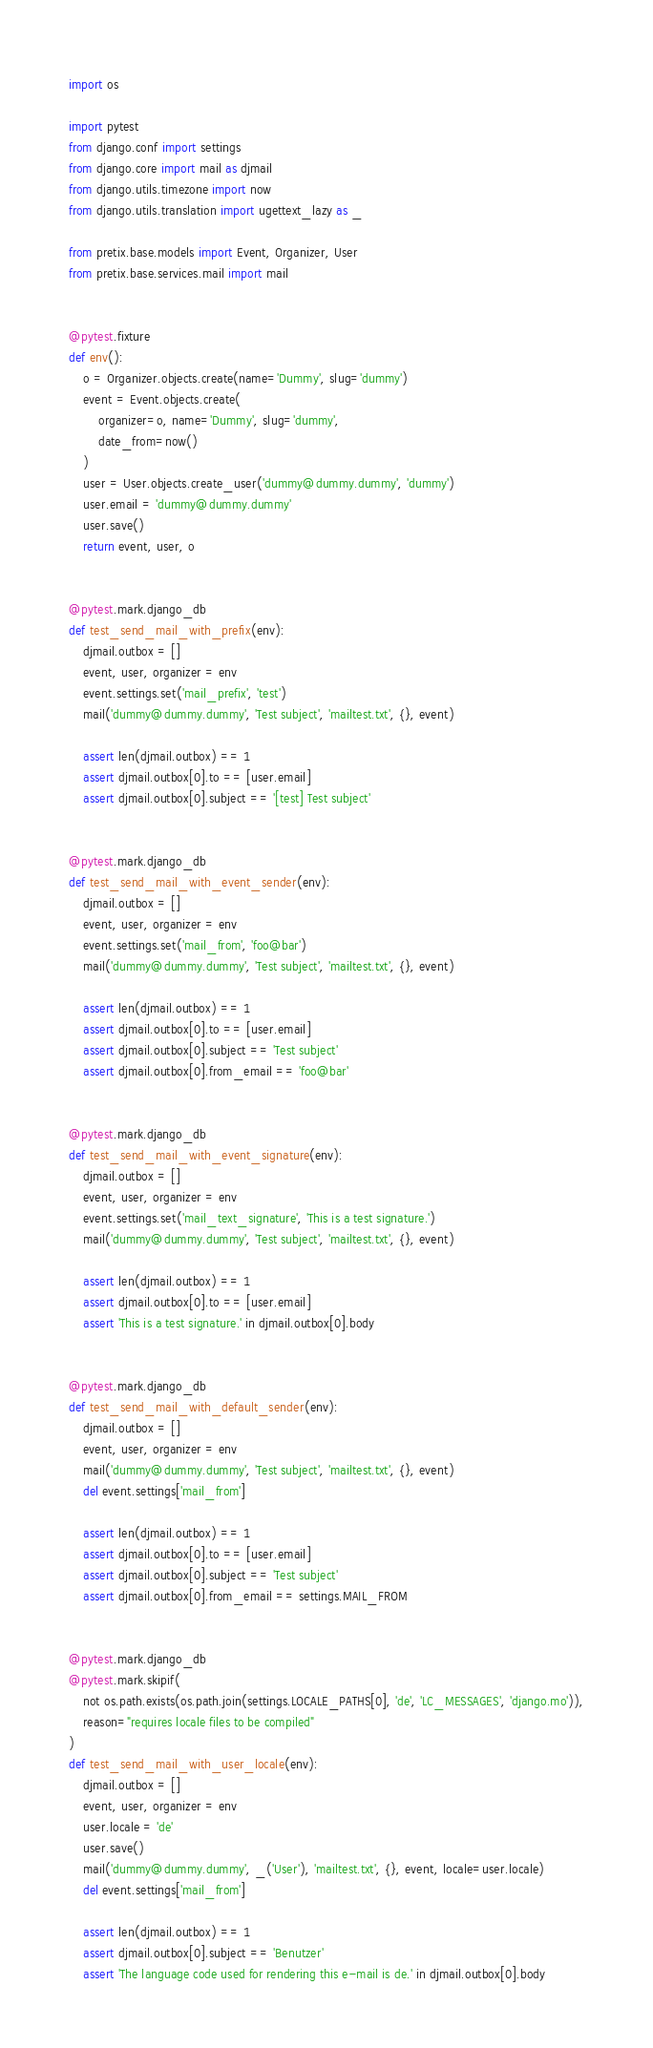<code> <loc_0><loc_0><loc_500><loc_500><_Python_>import os

import pytest
from django.conf import settings
from django.core import mail as djmail
from django.utils.timezone import now
from django.utils.translation import ugettext_lazy as _

from pretix.base.models import Event, Organizer, User
from pretix.base.services.mail import mail


@pytest.fixture
def env():
    o = Organizer.objects.create(name='Dummy', slug='dummy')
    event = Event.objects.create(
        organizer=o, name='Dummy', slug='dummy',
        date_from=now()
    )
    user = User.objects.create_user('dummy@dummy.dummy', 'dummy')
    user.email = 'dummy@dummy.dummy'
    user.save()
    return event, user, o


@pytest.mark.django_db
def test_send_mail_with_prefix(env):
    djmail.outbox = []
    event, user, organizer = env
    event.settings.set('mail_prefix', 'test')
    mail('dummy@dummy.dummy', 'Test subject', 'mailtest.txt', {}, event)

    assert len(djmail.outbox) == 1
    assert djmail.outbox[0].to == [user.email]
    assert djmail.outbox[0].subject == '[test] Test subject'


@pytest.mark.django_db
def test_send_mail_with_event_sender(env):
    djmail.outbox = []
    event, user, organizer = env
    event.settings.set('mail_from', 'foo@bar')
    mail('dummy@dummy.dummy', 'Test subject', 'mailtest.txt', {}, event)

    assert len(djmail.outbox) == 1
    assert djmail.outbox[0].to == [user.email]
    assert djmail.outbox[0].subject == 'Test subject'
    assert djmail.outbox[0].from_email == 'foo@bar'


@pytest.mark.django_db
def test_send_mail_with_event_signature(env):
    djmail.outbox = []
    event, user, organizer = env
    event.settings.set('mail_text_signature', 'This is a test signature.')
    mail('dummy@dummy.dummy', 'Test subject', 'mailtest.txt', {}, event)

    assert len(djmail.outbox) == 1
    assert djmail.outbox[0].to == [user.email]
    assert 'This is a test signature.' in djmail.outbox[0].body


@pytest.mark.django_db
def test_send_mail_with_default_sender(env):
    djmail.outbox = []
    event, user, organizer = env
    mail('dummy@dummy.dummy', 'Test subject', 'mailtest.txt', {}, event)
    del event.settings['mail_from']

    assert len(djmail.outbox) == 1
    assert djmail.outbox[0].to == [user.email]
    assert djmail.outbox[0].subject == 'Test subject'
    assert djmail.outbox[0].from_email == settings.MAIL_FROM


@pytest.mark.django_db
@pytest.mark.skipif(
    not os.path.exists(os.path.join(settings.LOCALE_PATHS[0], 'de', 'LC_MESSAGES', 'django.mo')),
    reason="requires locale files to be compiled"
)
def test_send_mail_with_user_locale(env):
    djmail.outbox = []
    event, user, organizer = env
    user.locale = 'de'
    user.save()
    mail('dummy@dummy.dummy', _('User'), 'mailtest.txt', {}, event, locale=user.locale)
    del event.settings['mail_from']

    assert len(djmail.outbox) == 1
    assert djmail.outbox[0].subject == 'Benutzer'
    assert 'The language code used for rendering this e-mail is de.' in djmail.outbox[0].body
</code> 